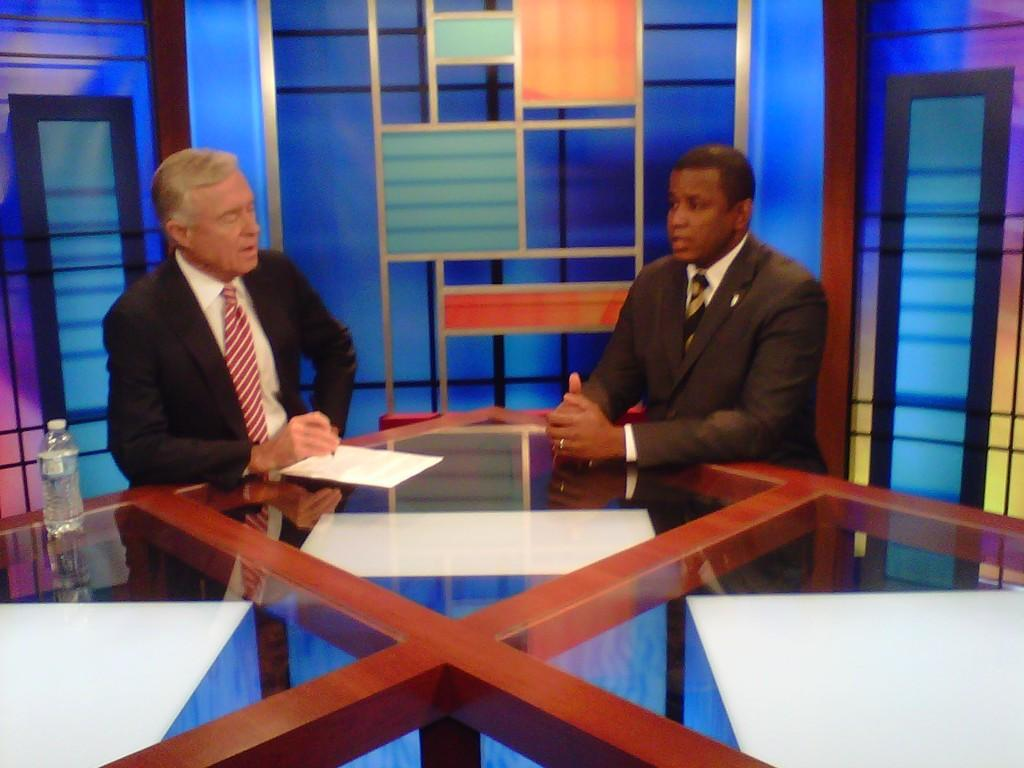How many people are sitting in the image? There are two persons sitting on chairs in the image. What is present on the table in the image? There is a bottle and a paper on the table in the image. Can you describe the background of the image? There is a glass and a door in the background of the image. What type of trees can be seen in the image? There are no trees visible in the image. Can you hear the voice of a monkey in the image? There is no monkey or any sound present in the image. 